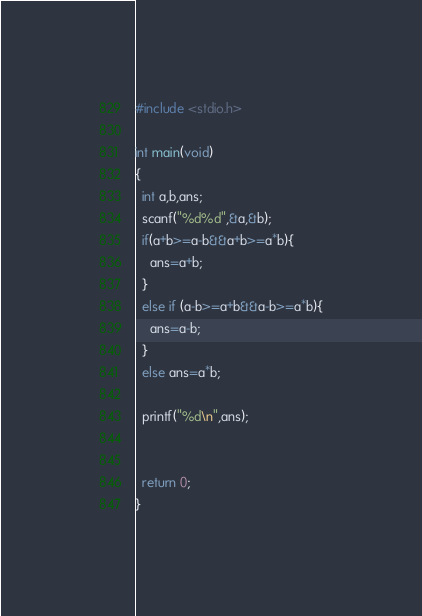<code> <loc_0><loc_0><loc_500><loc_500><_C_>#include <stdio.h>

int main(void)
{
  int a,b,ans;
  scanf("%d%d",&a,&b);
  if(a+b>=a-b&&a+b>=a*b){
    ans=a+b;
  }
  else if (a-b>=a+b&&a-b>=a*b){
    ans=a-b;
  }
  else ans=a*b;
  
  printf("%d\n",ans);
  
  
  return 0;
}</code> 